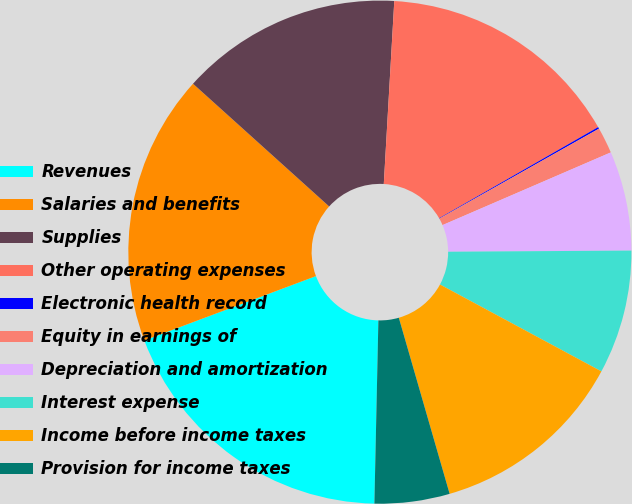Convert chart. <chart><loc_0><loc_0><loc_500><loc_500><pie_chart><fcel>Revenues<fcel>Salaries and benefits<fcel>Supplies<fcel>Other operating expenses<fcel>Electronic health record<fcel>Equity in earnings of<fcel>Depreciation and amortization<fcel>Interest expense<fcel>Income before income taxes<fcel>Provision for income taxes<nl><fcel>18.95%<fcel>17.38%<fcel>14.24%<fcel>15.81%<fcel>0.11%<fcel>1.68%<fcel>6.39%<fcel>7.96%<fcel>12.67%<fcel>4.82%<nl></chart> 